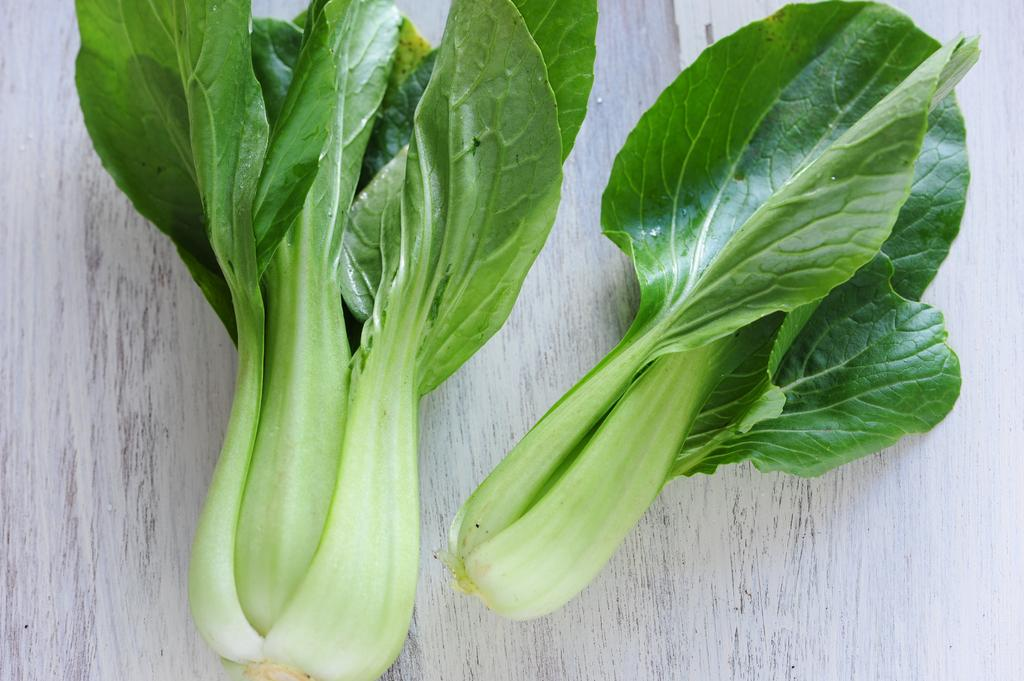What types of plants are in the image? There are two leafy vegetables in the image. How many drawers are visible in the image? There are no drawers present in the image; it features two leafy vegetables. What type of insect can be seen on the leafy vegetables in the image? There are no insects, including ladybugs, visible on the leafy vegetables in the image. 